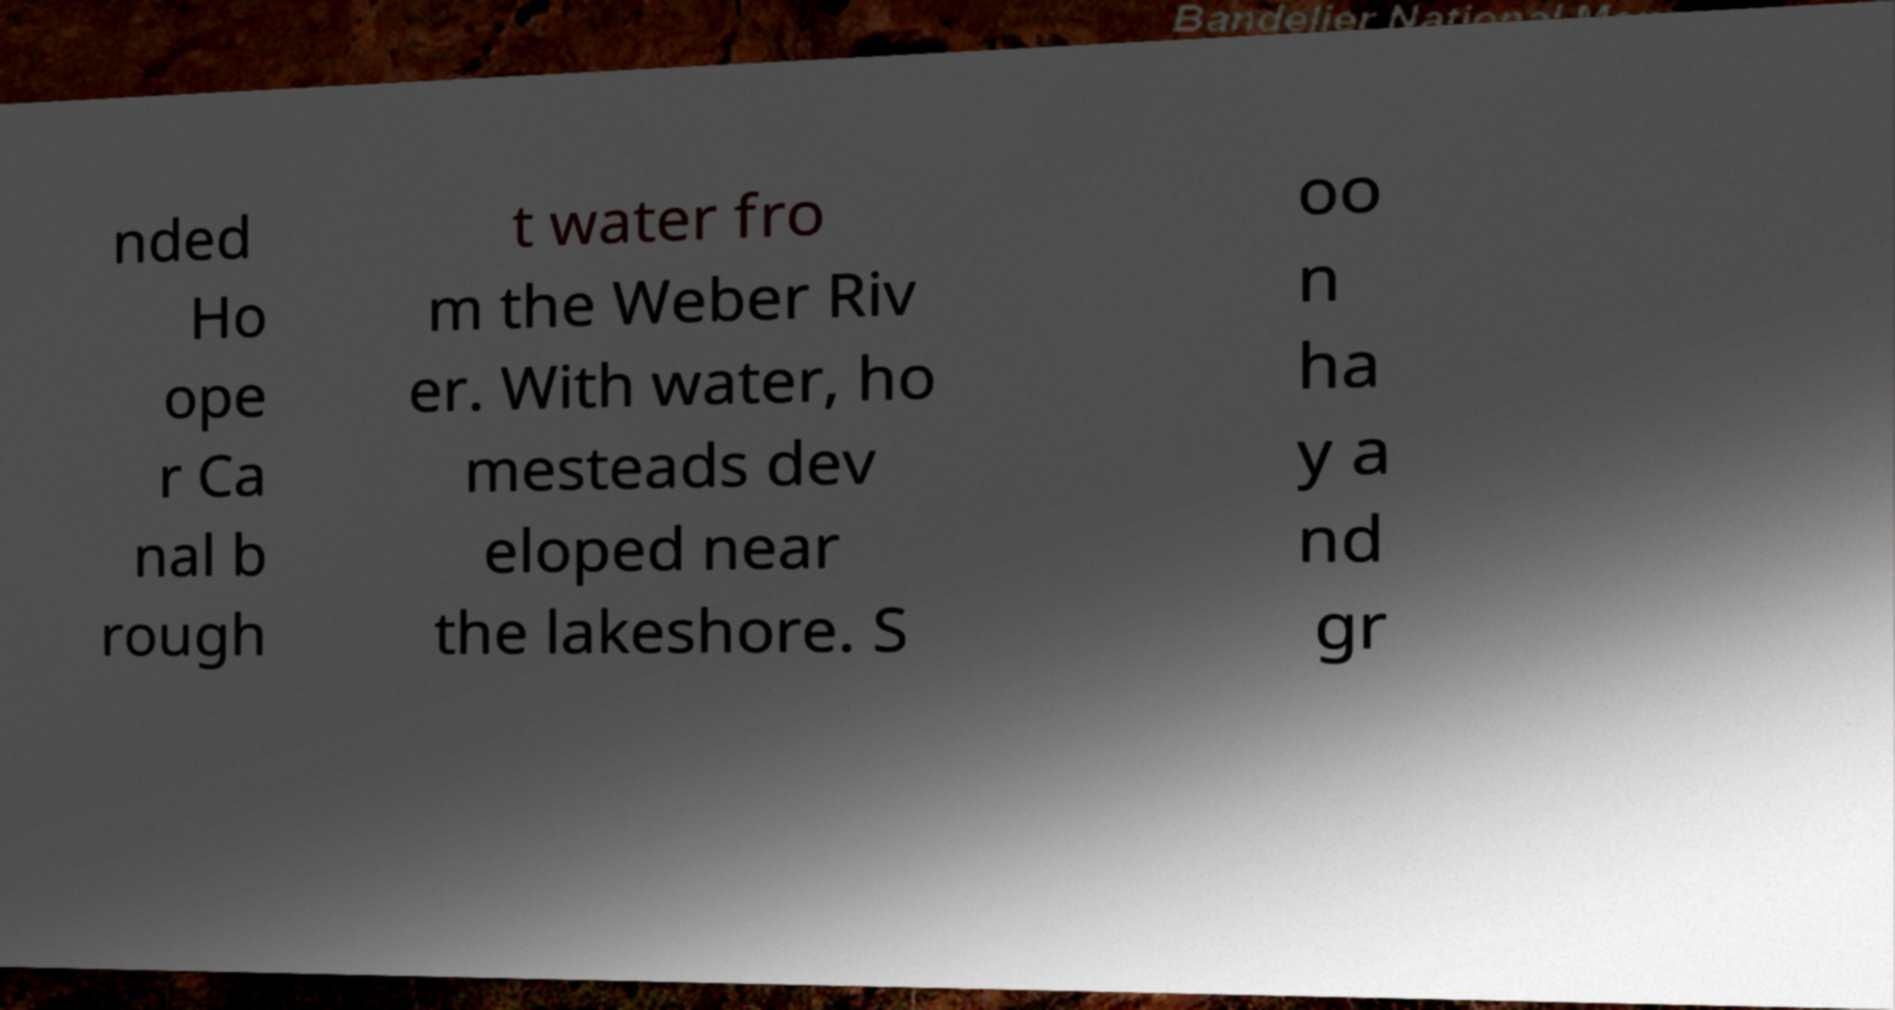Can you read and provide the text displayed in the image?This photo seems to have some interesting text. Can you extract and type it out for me? nded Ho ope r Ca nal b rough t water fro m the Weber Riv er. With water, ho mesteads dev eloped near the lakeshore. S oo n ha y a nd gr 